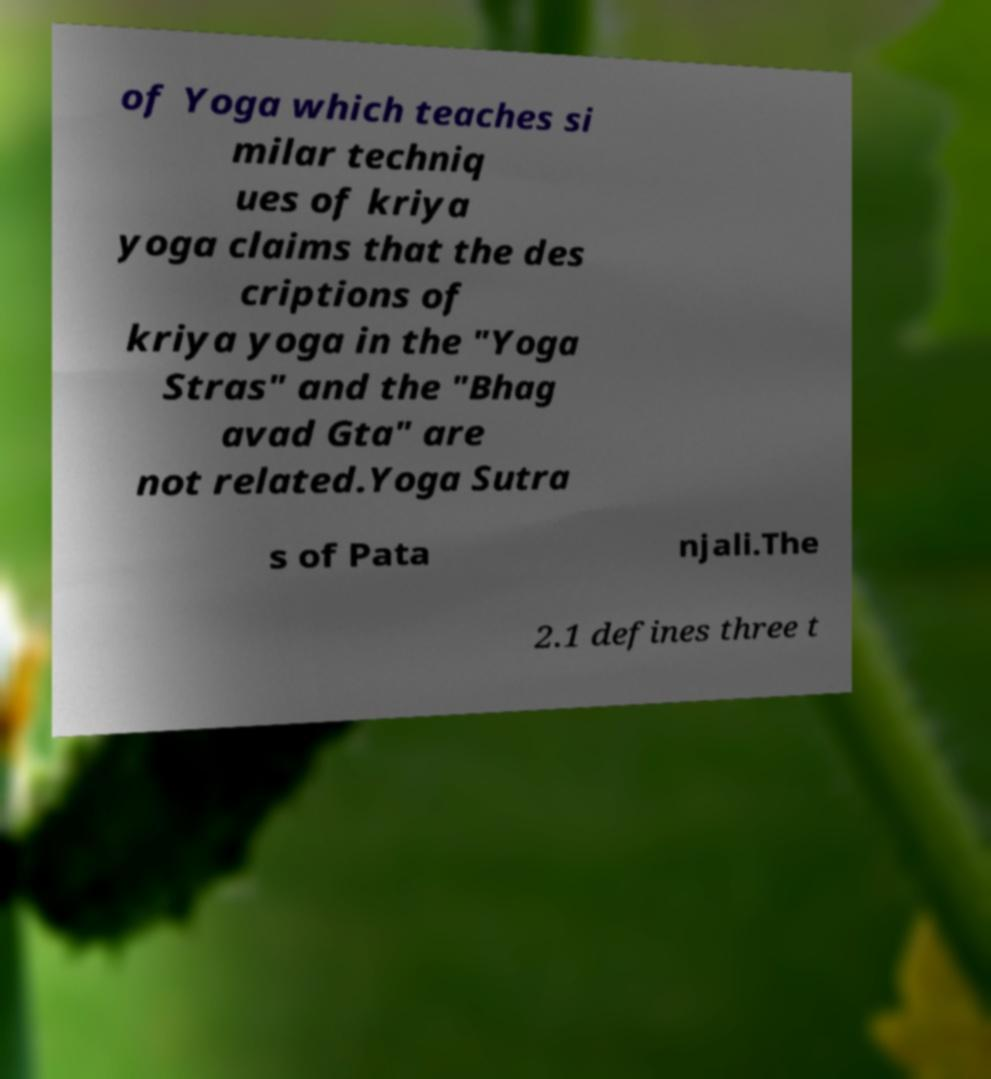Could you extract and type out the text from this image? of Yoga which teaches si milar techniq ues of kriya yoga claims that the des criptions of kriya yoga in the "Yoga Stras" and the "Bhag avad Gta" are not related.Yoga Sutra s of Pata njali.The 2.1 defines three t 